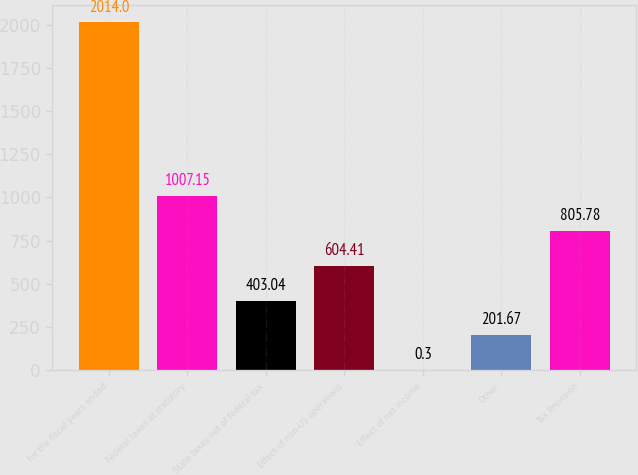Convert chart to OTSL. <chart><loc_0><loc_0><loc_500><loc_500><bar_chart><fcel>for the fiscal years ended<fcel>Federal taxes at statutory<fcel>State taxes net of federal tax<fcel>Effect of non-US operations<fcel>Effect of net income<fcel>Other<fcel>Tax Provision<nl><fcel>2014<fcel>1007.15<fcel>403.04<fcel>604.41<fcel>0.3<fcel>201.67<fcel>805.78<nl></chart> 